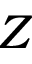<formula> <loc_0><loc_0><loc_500><loc_500>Z</formula> 